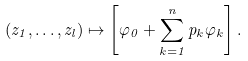Convert formula to latex. <formula><loc_0><loc_0><loc_500><loc_500>( z _ { 1 } , \dots , z _ { l } ) \mapsto \left [ \varphi _ { 0 } + \sum _ { k = 1 } ^ { n } p _ { k } \varphi _ { k } \right ] .</formula> 